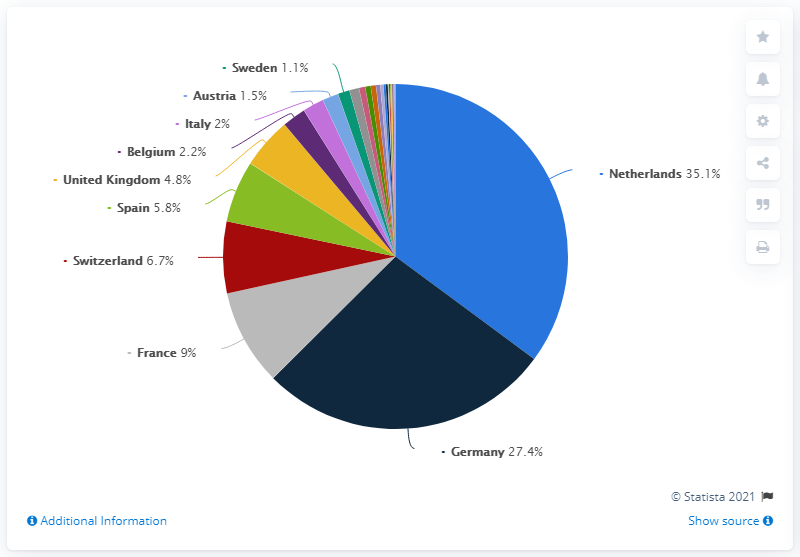Indicate a few pertinent items in this graphic. Germany has the oldest social health care system in the world. I'm sorry, but I'm not sure what you are asking. Could you please clarify your question? In 2019, the market share of the German health insurance market was 27.4%. The country with the highest value is the Netherlands. 